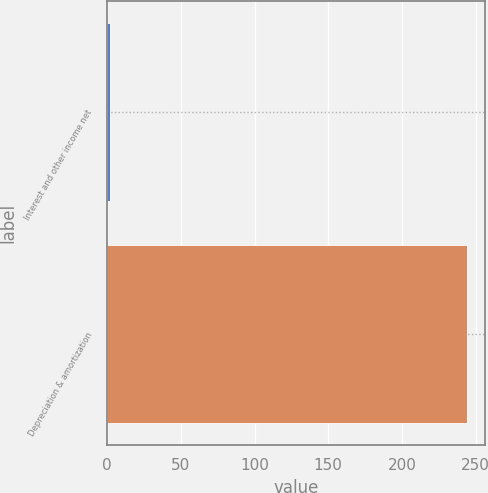<chart> <loc_0><loc_0><loc_500><loc_500><bar_chart><fcel>Interest and other income net<fcel>Depreciation & amortization<nl><fcel>2<fcel>244<nl></chart> 